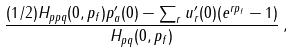<formula> <loc_0><loc_0><loc_500><loc_500>\frac { ( 1 / 2 ) H _ { p p q } ( 0 , p _ { f } ) p _ { a } ^ { \prime } ( 0 ) - \sum _ { r } u _ { r } ^ { \prime } ( 0 ) ( e ^ { r p _ { f } } - 1 ) } { H _ { p q } ( 0 , p _ { f } ) } \, ,</formula> 